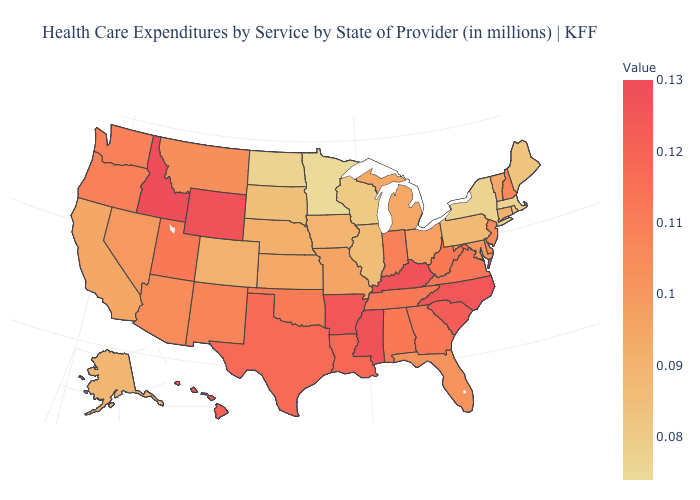Which states have the highest value in the USA?
Give a very brief answer. Idaho. Among the states that border Illinois , which have the highest value?
Concise answer only. Kentucky. Does Vermont have a higher value than Pennsylvania?
Give a very brief answer. Yes. Does Vermont have the lowest value in the Northeast?
Quick response, please. No. Is the legend a continuous bar?
Write a very short answer. Yes. 